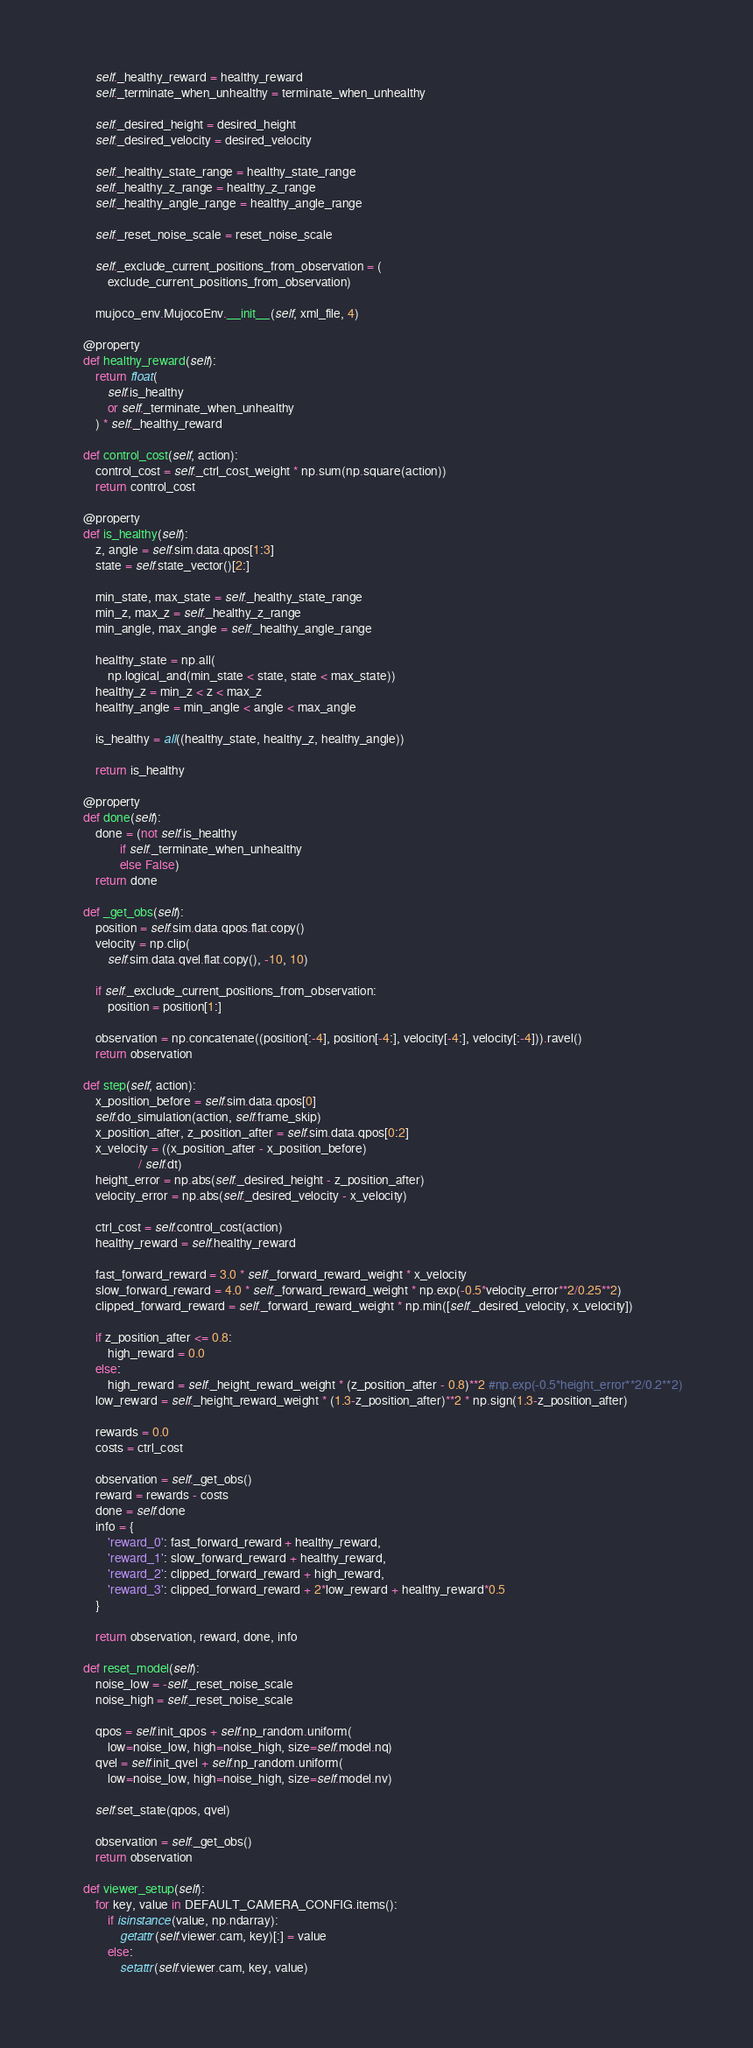<code> <loc_0><loc_0><loc_500><loc_500><_Python_>
        self._healthy_reward = healthy_reward
        self._terminate_when_unhealthy = terminate_when_unhealthy

        self._desired_height = desired_height
        self._desired_velocity = desired_velocity

        self._healthy_state_range = healthy_state_range
        self._healthy_z_range = healthy_z_range
        self._healthy_angle_range = healthy_angle_range

        self._reset_noise_scale = reset_noise_scale

        self._exclude_current_positions_from_observation = (
            exclude_current_positions_from_observation)

        mujoco_env.MujocoEnv.__init__(self, xml_file, 4)

    @property
    def healthy_reward(self):
        return float(
            self.is_healthy
            or self._terminate_when_unhealthy
        ) * self._healthy_reward

    def control_cost(self, action):
        control_cost = self._ctrl_cost_weight * np.sum(np.square(action))
        return control_cost

    @property
    def is_healthy(self):
        z, angle = self.sim.data.qpos[1:3]
        state = self.state_vector()[2:]

        min_state, max_state = self._healthy_state_range
        min_z, max_z = self._healthy_z_range
        min_angle, max_angle = self._healthy_angle_range

        healthy_state = np.all(
            np.logical_and(min_state < state, state < max_state))
        healthy_z = min_z < z < max_z
        healthy_angle = min_angle < angle < max_angle

        is_healthy = all((healthy_state, healthy_z, healthy_angle))

        return is_healthy

    @property
    def done(self):
        done = (not self.is_healthy
                if self._terminate_when_unhealthy
                else False)
        return done

    def _get_obs(self):
        position = self.sim.data.qpos.flat.copy()
        velocity = np.clip(
            self.sim.data.qvel.flat.copy(), -10, 10)

        if self._exclude_current_positions_from_observation:
            position = position[1:]

        observation = np.concatenate((position[:-4], position[-4:], velocity[-4:], velocity[:-4])).ravel()
        return observation

    def step(self, action):
        x_position_before = self.sim.data.qpos[0]
        self.do_simulation(action, self.frame_skip)
        x_position_after, z_position_after = self.sim.data.qpos[0:2]
        x_velocity = ((x_position_after - x_position_before)
                      / self.dt)
        height_error = np.abs(self._desired_height - z_position_after)
        velocity_error = np.abs(self._desired_velocity - x_velocity)

        ctrl_cost = self.control_cost(action)
        healthy_reward = self.healthy_reward

        fast_forward_reward = 3.0 * self._forward_reward_weight * x_velocity
        slow_forward_reward = 4.0 * self._forward_reward_weight * np.exp(-0.5*velocity_error**2/0.25**2)
        clipped_forward_reward = self._forward_reward_weight * np.min([self._desired_velocity, x_velocity])
        
        if z_position_after <= 0.8:
            high_reward = 0.0
        else:
            high_reward = self._height_reward_weight * (z_position_after - 0.8)**2 #np.exp(-0.5*height_error**2/0.2**2)
        low_reward = self._height_reward_weight * (1.3-z_position_after)**2 * np.sign(1.3-z_position_after)

        rewards = 0.0
        costs = ctrl_cost

        observation = self._get_obs()
        reward = rewards - costs
        done = self.done
        info = {
            'reward_0': fast_forward_reward + healthy_reward,
            'reward_1': slow_forward_reward + healthy_reward,
            'reward_2': clipped_forward_reward + high_reward,
            'reward_3': clipped_forward_reward + 2*low_reward + healthy_reward*0.5
        }

        return observation, reward, done, info

    def reset_model(self):
        noise_low = -self._reset_noise_scale
        noise_high = self._reset_noise_scale

        qpos = self.init_qpos + self.np_random.uniform(
            low=noise_low, high=noise_high, size=self.model.nq)
        qvel = self.init_qvel + self.np_random.uniform(
            low=noise_low, high=noise_high, size=self.model.nv)

        self.set_state(qpos, qvel)

        observation = self._get_obs()
        return observation

    def viewer_setup(self):
        for key, value in DEFAULT_CAMERA_CONFIG.items():
            if isinstance(value, np.ndarray):
                getattr(self.viewer.cam, key)[:] = value
            else:
                setattr(self.viewer.cam, key, value)
</code> 